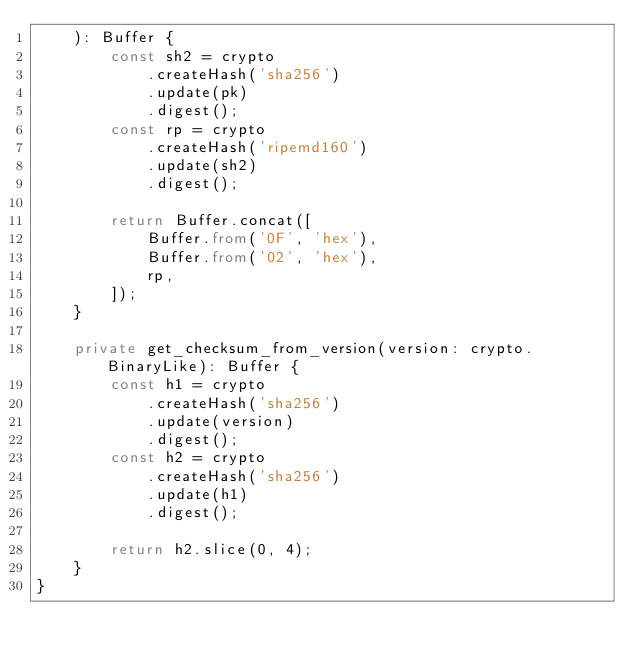Convert code to text. <code><loc_0><loc_0><loc_500><loc_500><_TypeScript_>    ): Buffer {
        const sh2 = crypto
            .createHash('sha256')
            .update(pk)
            .digest();
        const rp = crypto
            .createHash('ripemd160')
            .update(sh2)
            .digest();

        return Buffer.concat([
            Buffer.from('0F', 'hex'),
            Buffer.from('02', 'hex'),
            rp,
        ]);
    }

    private get_checksum_from_version(version: crypto.BinaryLike): Buffer {
        const h1 = crypto
            .createHash('sha256')
            .update(version)
            .digest();
        const h2 = crypto
            .createHash('sha256')
            .update(h1)
            .digest();

        return h2.slice(0, 4);
    }
}
</code> 